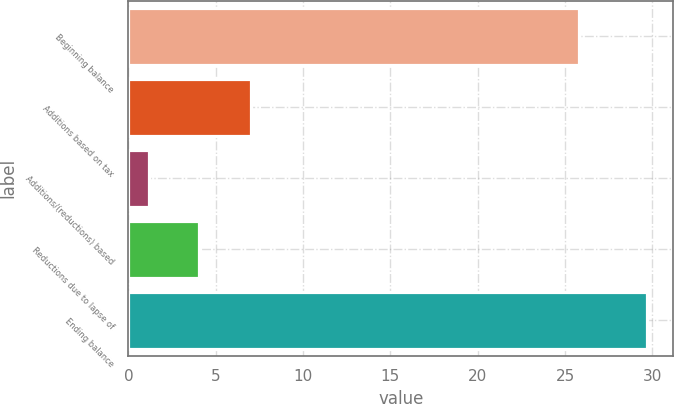Convert chart. <chart><loc_0><loc_0><loc_500><loc_500><bar_chart><fcel>Beginning balance<fcel>Additions based on tax<fcel>Additions/(reductions) based<fcel>Reductions due to lapse of<fcel>Ending balance<nl><fcel>25.8<fcel>7<fcel>1.2<fcel>4.05<fcel>29.7<nl></chart> 